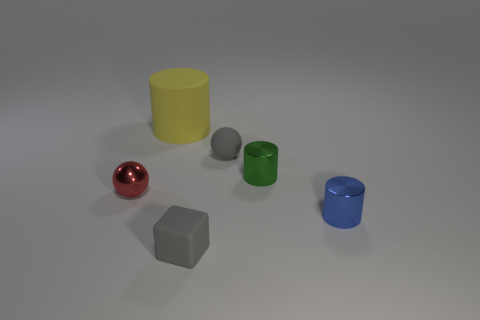Subtract all tiny shiny cylinders. How many cylinders are left? 1 Add 1 tiny blue metal cylinders. How many objects exist? 7 Subtract all blocks. How many objects are left? 5 Add 4 large blue matte cubes. How many large blue matte cubes exist? 4 Subtract 0 red cylinders. How many objects are left? 6 Subtract all gray cubes. Subtract all small rubber balls. How many objects are left? 4 Add 3 metal spheres. How many metal spheres are left? 4 